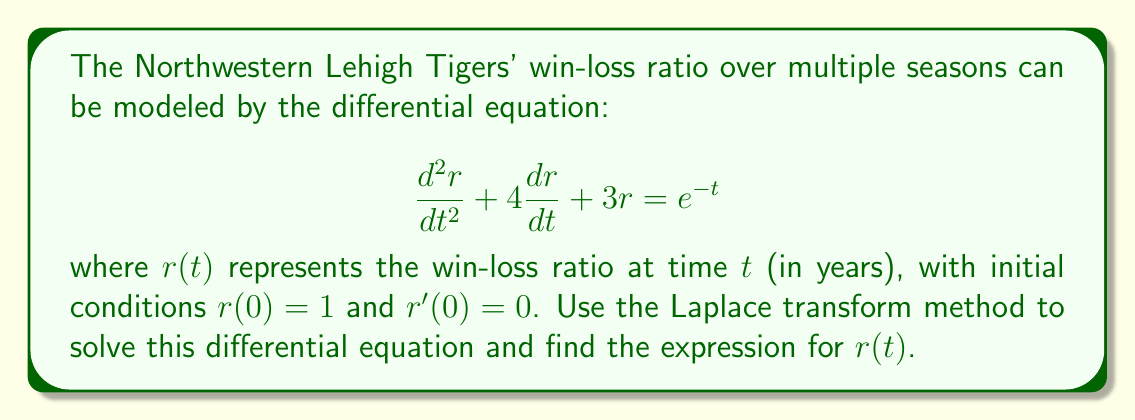Show me your answer to this math problem. Let's solve this step-by-step using Laplace transforms:

1) Take the Laplace transform of both sides of the equation:
   $$\mathcal{L}\left\{\frac{d^2r}{dt^2} + 4\frac{dr}{dt} + 3r\right\} = \mathcal{L}\{e^{-t}\}$$

2) Using Laplace transform properties:
   $$s^2R(s) - sr(0) - r'(0) + 4[sR(s) - r(0)] + 3R(s) = \frac{1}{s+1}$$

3) Substitute the initial conditions $r(0) = 1$ and $r'(0) = 0$:
   $$s^2R(s) - s + 4sR(s) - 4 + 3R(s) = \frac{1}{s+1}$$

4) Simplify:
   $$(s^2 + 4s + 3)R(s) = \frac{1}{s+1} + s + 4$$

5) Solve for $R(s)$:
   $$R(s) = \frac{1}{s^2 + 4s + 3} \cdot \left(\frac{1}{s+1} + s + 4\right)$$

6) Simplify the right side:
   $$R(s) = \frac{s^2 + 5s + 5}{(s^2 + 4s + 3)(s+1)}$$

7) Perform partial fraction decomposition:
   $$R(s) = \frac{A}{s+1} + \frac{B}{s+3} + \frac{C}{s+1}$$

8) Solve for A, B, and C:
   $$A = \frac{1}{2}, B = -\frac{1}{2}, C = 1$$

9) Rewrite $R(s)$:
   $$R(s) = \frac{1}{2(s+1)} - \frac{1}{2(s+3)} + \frac{1}{s+1}$$

10) Take the inverse Laplace transform:
    $$r(t) = \frac{1}{2}e^{-t} - \frac{1}{2}e^{-3t} + e^{-t}$$

11) Simplify:
    $$r(t) = \frac{3}{2}e^{-t} - \frac{1}{2}e^{-3t}$$
Answer: $r(t) = \frac{3}{2}e^{-t} - \frac{1}{2}e^{-3t}$ 